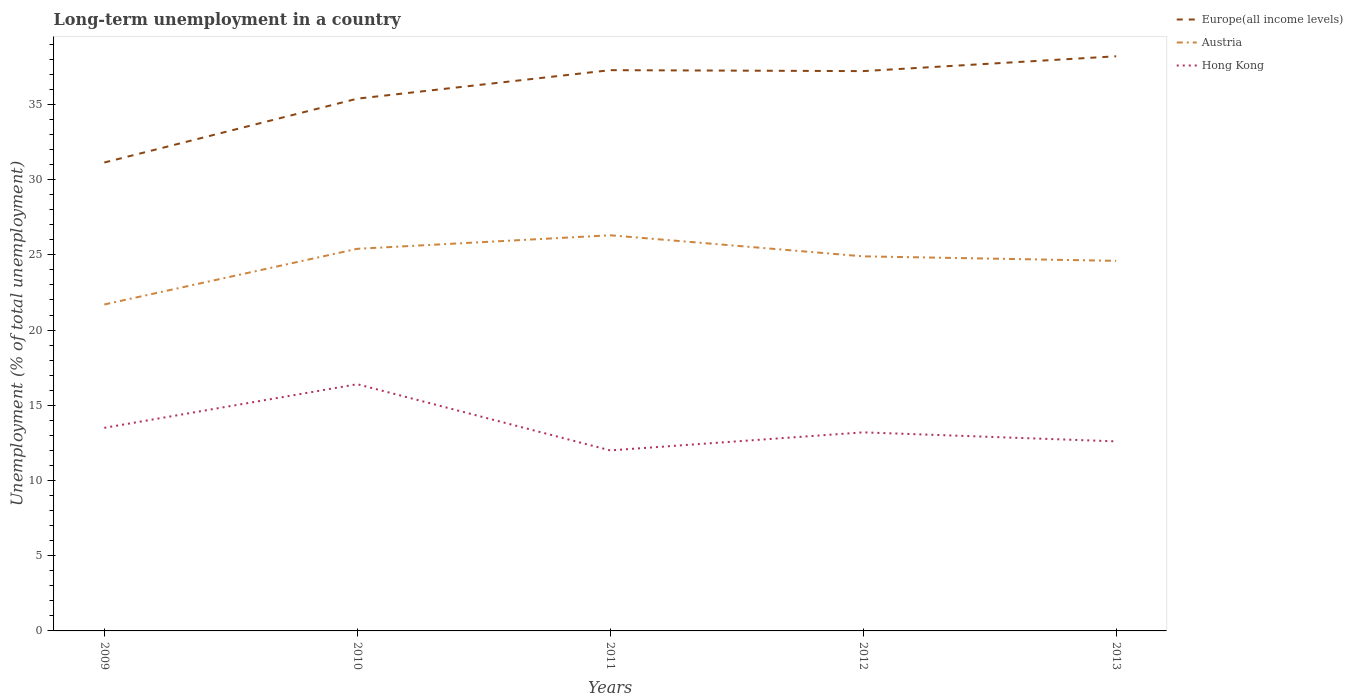How many different coloured lines are there?
Provide a succinct answer. 3. Does the line corresponding to Hong Kong intersect with the line corresponding to Austria?
Your answer should be very brief. No. Is the number of lines equal to the number of legend labels?
Provide a succinct answer. Yes. Across all years, what is the maximum percentage of long-term unemployed population in Austria?
Offer a terse response. 21.7. What is the total percentage of long-term unemployed population in Hong Kong in the graph?
Your response must be concise. 0.9. What is the difference between the highest and the second highest percentage of long-term unemployed population in Europe(all income levels)?
Offer a very short reply. 7.06. Is the percentage of long-term unemployed population in Austria strictly greater than the percentage of long-term unemployed population in Hong Kong over the years?
Keep it short and to the point. No. How many lines are there?
Your response must be concise. 3. How many years are there in the graph?
Provide a succinct answer. 5. What is the difference between two consecutive major ticks on the Y-axis?
Ensure brevity in your answer.  5. Where does the legend appear in the graph?
Your answer should be very brief. Top right. How are the legend labels stacked?
Provide a short and direct response. Vertical. What is the title of the graph?
Ensure brevity in your answer.  Long-term unemployment in a country. Does "Tunisia" appear as one of the legend labels in the graph?
Provide a short and direct response. No. What is the label or title of the Y-axis?
Make the answer very short. Unemployment (% of total unemployment). What is the Unemployment (% of total unemployment) in Europe(all income levels) in 2009?
Give a very brief answer. 31.14. What is the Unemployment (% of total unemployment) of Austria in 2009?
Offer a terse response. 21.7. What is the Unemployment (% of total unemployment) in Europe(all income levels) in 2010?
Give a very brief answer. 35.38. What is the Unemployment (% of total unemployment) of Austria in 2010?
Your response must be concise. 25.4. What is the Unemployment (% of total unemployment) of Hong Kong in 2010?
Ensure brevity in your answer.  16.4. What is the Unemployment (% of total unemployment) in Europe(all income levels) in 2011?
Provide a short and direct response. 37.28. What is the Unemployment (% of total unemployment) in Austria in 2011?
Provide a succinct answer. 26.3. What is the Unemployment (% of total unemployment) in Europe(all income levels) in 2012?
Ensure brevity in your answer.  37.21. What is the Unemployment (% of total unemployment) in Austria in 2012?
Keep it short and to the point. 24.9. What is the Unemployment (% of total unemployment) in Hong Kong in 2012?
Make the answer very short. 13.2. What is the Unemployment (% of total unemployment) of Europe(all income levels) in 2013?
Offer a terse response. 38.2. What is the Unemployment (% of total unemployment) of Austria in 2013?
Your answer should be compact. 24.6. What is the Unemployment (% of total unemployment) in Hong Kong in 2013?
Offer a very short reply. 12.6. Across all years, what is the maximum Unemployment (% of total unemployment) in Europe(all income levels)?
Ensure brevity in your answer.  38.2. Across all years, what is the maximum Unemployment (% of total unemployment) in Austria?
Give a very brief answer. 26.3. Across all years, what is the maximum Unemployment (% of total unemployment) of Hong Kong?
Keep it short and to the point. 16.4. Across all years, what is the minimum Unemployment (% of total unemployment) of Europe(all income levels)?
Give a very brief answer. 31.14. Across all years, what is the minimum Unemployment (% of total unemployment) of Austria?
Your response must be concise. 21.7. What is the total Unemployment (% of total unemployment) of Europe(all income levels) in the graph?
Offer a very short reply. 179.2. What is the total Unemployment (% of total unemployment) in Austria in the graph?
Your response must be concise. 122.9. What is the total Unemployment (% of total unemployment) of Hong Kong in the graph?
Your response must be concise. 67.7. What is the difference between the Unemployment (% of total unemployment) of Europe(all income levels) in 2009 and that in 2010?
Your answer should be very brief. -4.24. What is the difference between the Unemployment (% of total unemployment) in Austria in 2009 and that in 2010?
Give a very brief answer. -3.7. What is the difference between the Unemployment (% of total unemployment) of Hong Kong in 2009 and that in 2010?
Offer a very short reply. -2.9. What is the difference between the Unemployment (% of total unemployment) in Europe(all income levels) in 2009 and that in 2011?
Offer a terse response. -6.14. What is the difference between the Unemployment (% of total unemployment) in Hong Kong in 2009 and that in 2011?
Your response must be concise. 1.5. What is the difference between the Unemployment (% of total unemployment) of Europe(all income levels) in 2009 and that in 2012?
Provide a succinct answer. -6.08. What is the difference between the Unemployment (% of total unemployment) in Hong Kong in 2009 and that in 2012?
Offer a terse response. 0.3. What is the difference between the Unemployment (% of total unemployment) in Europe(all income levels) in 2009 and that in 2013?
Offer a terse response. -7.06. What is the difference between the Unemployment (% of total unemployment) in Austria in 2009 and that in 2013?
Offer a terse response. -2.9. What is the difference between the Unemployment (% of total unemployment) of Hong Kong in 2009 and that in 2013?
Your response must be concise. 0.9. What is the difference between the Unemployment (% of total unemployment) in Europe(all income levels) in 2010 and that in 2011?
Give a very brief answer. -1.89. What is the difference between the Unemployment (% of total unemployment) of Hong Kong in 2010 and that in 2011?
Give a very brief answer. 4.4. What is the difference between the Unemployment (% of total unemployment) of Europe(all income levels) in 2010 and that in 2012?
Provide a succinct answer. -1.83. What is the difference between the Unemployment (% of total unemployment) in Hong Kong in 2010 and that in 2012?
Your answer should be compact. 3.2. What is the difference between the Unemployment (% of total unemployment) of Europe(all income levels) in 2010 and that in 2013?
Your response must be concise. -2.82. What is the difference between the Unemployment (% of total unemployment) of Hong Kong in 2010 and that in 2013?
Make the answer very short. 3.8. What is the difference between the Unemployment (% of total unemployment) in Europe(all income levels) in 2011 and that in 2012?
Keep it short and to the point. 0.06. What is the difference between the Unemployment (% of total unemployment) of Europe(all income levels) in 2011 and that in 2013?
Offer a very short reply. -0.92. What is the difference between the Unemployment (% of total unemployment) in Hong Kong in 2011 and that in 2013?
Offer a terse response. -0.6. What is the difference between the Unemployment (% of total unemployment) of Europe(all income levels) in 2012 and that in 2013?
Offer a terse response. -0.99. What is the difference between the Unemployment (% of total unemployment) of Austria in 2012 and that in 2013?
Offer a very short reply. 0.3. What is the difference between the Unemployment (% of total unemployment) of Europe(all income levels) in 2009 and the Unemployment (% of total unemployment) of Austria in 2010?
Your response must be concise. 5.74. What is the difference between the Unemployment (% of total unemployment) of Europe(all income levels) in 2009 and the Unemployment (% of total unemployment) of Hong Kong in 2010?
Give a very brief answer. 14.74. What is the difference between the Unemployment (% of total unemployment) in Europe(all income levels) in 2009 and the Unemployment (% of total unemployment) in Austria in 2011?
Keep it short and to the point. 4.84. What is the difference between the Unemployment (% of total unemployment) in Europe(all income levels) in 2009 and the Unemployment (% of total unemployment) in Hong Kong in 2011?
Give a very brief answer. 19.14. What is the difference between the Unemployment (% of total unemployment) in Austria in 2009 and the Unemployment (% of total unemployment) in Hong Kong in 2011?
Keep it short and to the point. 9.7. What is the difference between the Unemployment (% of total unemployment) in Europe(all income levels) in 2009 and the Unemployment (% of total unemployment) in Austria in 2012?
Your answer should be compact. 6.24. What is the difference between the Unemployment (% of total unemployment) of Europe(all income levels) in 2009 and the Unemployment (% of total unemployment) of Hong Kong in 2012?
Keep it short and to the point. 17.94. What is the difference between the Unemployment (% of total unemployment) of Europe(all income levels) in 2009 and the Unemployment (% of total unemployment) of Austria in 2013?
Your response must be concise. 6.54. What is the difference between the Unemployment (% of total unemployment) of Europe(all income levels) in 2009 and the Unemployment (% of total unemployment) of Hong Kong in 2013?
Provide a short and direct response. 18.54. What is the difference between the Unemployment (% of total unemployment) of Austria in 2009 and the Unemployment (% of total unemployment) of Hong Kong in 2013?
Ensure brevity in your answer.  9.1. What is the difference between the Unemployment (% of total unemployment) of Europe(all income levels) in 2010 and the Unemployment (% of total unemployment) of Austria in 2011?
Keep it short and to the point. 9.08. What is the difference between the Unemployment (% of total unemployment) of Europe(all income levels) in 2010 and the Unemployment (% of total unemployment) of Hong Kong in 2011?
Provide a short and direct response. 23.38. What is the difference between the Unemployment (% of total unemployment) in Europe(all income levels) in 2010 and the Unemployment (% of total unemployment) in Austria in 2012?
Your response must be concise. 10.48. What is the difference between the Unemployment (% of total unemployment) in Europe(all income levels) in 2010 and the Unemployment (% of total unemployment) in Hong Kong in 2012?
Keep it short and to the point. 22.18. What is the difference between the Unemployment (% of total unemployment) of Austria in 2010 and the Unemployment (% of total unemployment) of Hong Kong in 2012?
Your response must be concise. 12.2. What is the difference between the Unemployment (% of total unemployment) of Europe(all income levels) in 2010 and the Unemployment (% of total unemployment) of Austria in 2013?
Give a very brief answer. 10.78. What is the difference between the Unemployment (% of total unemployment) of Europe(all income levels) in 2010 and the Unemployment (% of total unemployment) of Hong Kong in 2013?
Provide a short and direct response. 22.78. What is the difference between the Unemployment (% of total unemployment) of Austria in 2010 and the Unemployment (% of total unemployment) of Hong Kong in 2013?
Keep it short and to the point. 12.8. What is the difference between the Unemployment (% of total unemployment) in Europe(all income levels) in 2011 and the Unemployment (% of total unemployment) in Austria in 2012?
Make the answer very short. 12.38. What is the difference between the Unemployment (% of total unemployment) in Europe(all income levels) in 2011 and the Unemployment (% of total unemployment) in Hong Kong in 2012?
Your response must be concise. 24.08. What is the difference between the Unemployment (% of total unemployment) of Austria in 2011 and the Unemployment (% of total unemployment) of Hong Kong in 2012?
Your answer should be compact. 13.1. What is the difference between the Unemployment (% of total unemployment) in Europe(all income levels) in 2011 and the Unemployment (% of total unemployment) in Austria in 2013?
Provide a succinct answer. 12.68. What is the difference between the Unemployment (% of total unemployment) in Europe(all income levels) in 2011 and the Unemployment (% of total unemployment) in Hong Kong in 2013?
Offer a very short reply. 24.68. What is the difference between the Unemployment (% of total unemployment) of Europe(all income levels) in 2012 and the Unemployment (% of total unemployment) of Austria in 2013?
Offer a very short reply. 12.61. What is the difference between the Unemployment (% of total unemployment) in Europe(all income levels) in 2012 and the Unemployment (% of total unemployment) in Hong Kong in 2013?
Your response must be concise. 24.61. What is the difference between the Unemployment (% of total unemployment) in Austria in 2012 and the Unemployment (% of total unemployment) in Hong Kong in 2013?
Provide a succinct answer. 12.3. What is the average Unemployment (% of total unemployment) in Europe(all income levels) per year?
Your answer should be compact. 35.84. What is the average Unemployment (% of total unemployment) of Austria per year?
Offer a terse response. 24.58. What is the average Unemployment (% of total unemployment) in Hong Kong per year?
Offer a very short reply. 13.54. In the year 2009, what is the difference between the Unemployment (% of total unemployment) of Europe(all income levels) and Unemployment (% of total unemployment) of Austria?
Offer a very short reply. 9.44. In the year 2009, what is the difference between the Unemployment (% of total unemployment) in Europe(all income levels) and Unemployment (% of total unemployment) in Hong Kong?
Your answer should be very brief. 17.64. In the year 2009, what is the difference between the Unemployment (% of total unemployment) of Austria and Unemployment (% of total unemployment) of Hong Kong?
Provide a succinct answer. 8.2. In the year 2010, what is the difference between the Unemployment (% of total unemployment) of Europe(all income levels) and Unemployment (% of total unemployment) of Austria?
Give a very brief answer. 9.98. In the year 2010, what is the difference between the Unemployment (% of total unemployment) in Europe(all income levels) and Unemployment (% of total unemployment) in Hong Kong?
Your answer should be compact. 18.98. In the year 2011, what is the difference between the Unemployment (% of total unemployment) of Europe(all income levels) and Unemployment (% of total unemployment) of Austria?
Give a very brief answer. 10.98. In the year 2011, what is the difference between the Unemployment (% of total unemployment) of Europe(all income levels) and Unemployment (% of total unemployment) of Hong Kong?
Your response must be concise. 25.28. In the year 2012, what is the difference between the Unemployment (% of total unemployment) in Europe(all income levels) and Unemployment (% of total unemployment) in Austria?
Make the answer very short. 12.31. In the year 2012, what is the difference between the Unemployment (% of total unemployment) of Europe(all income levels) and Unemployment (% of total unemployment) of Hong Kong?
Offer a very short reply. 24.01. In the year 2012, what is the difference between the Unemployment (% of total unemployment) of Austria and Unemployment (% of total unemployment) of Hong Kong?
Your answer should be compact. 11.7. In the year 2013, what is the difference between the Unemployment (% of total unemployment) in Europe(all income levels) and Unemployment (% of total unemployment) in Austria?
Give a very brief answer. 13.6. In the year 2013, what is the difference between the Unemployment (% of total unemployment) of Europe(all income levels) and Unemployment (% of total unemployment) of Hong Kong?
Make the answer very short. 25.6. In the year 2013, what is the difference between the Unemployment (% of total unemployment) of Austria and Unemployment (% of total unemployment) of Hong Kong?
Offer a very short reply. 12. What is the ratio of the Unemployment (% of total unemployment) of Europe(all income levels) in 2009 to that in 2010?
Provide a succinct answer. 0.88. What is the ratio of the Unemployment (% of total unemployment) in Austria in 2009 to that in 2010?
Provide a succinct answer. 0.85. What is the ratio of the Unemployment (% of total unemployment) in Hong Kong in 2009 to that in 2010?
Make the answer very short. 0.82. What is the ratio of the Unemployment (% of total unemployment) in Europe(all income levels) in 2009 to that in 2011?
Keep it short and to the point. 0.84. What is the ratio of the Unemployment (% of total unemployment) of Austria in 2009 to that in 2011?
Offer a very short reply. 0.83. What is the ratio of the Unemployment (% of total unemployment) in Hong Kong in 2009 to that in 2011?
Ensure brevity in your answer.  1.12. What is the ratio of the Unemployment (% of total unemployment) in Europe(all income levels) in 2009 to that in 2012?
Your response must be concise. 0.84. What is the ratio of the Unemployment (% of total unemployment) in Austria in 2009 to that in 2012?
Provide a succinct answer. 0.87. What is the ratio of the Unemployment (% of total unemployment) in Hong Kong in 2009 to that in 2012?
Keep it short and to the point. 1.02. What is the ratio of the Unemployment (% of total unemployment) in Europe(all income levels) in 2009 to that in 2013?
Give a very brief answer. 0.82. What is the ratio of the Unemployment (% of total unemployment) of Austria in 2009 to that in 2013?
Ensure brevity in your answer.  0.88. What is the ratio of the Unemployment (% of total unemployment) of Hong Kong in 2009 to that in 2013?
Provide a succinct answer. 1.07. What is the ratio of the Unemployment (% of total unemployment) of Europe(all income levels) in 2010 to that in 2011?
Your answer should be very brief. 0.95. What is the ratio of the Unemployment (% of total unemployment) in Austria in 2010 to that in 2011?
Your answer should be very brief. 0.97. What is the ratio of the Unemployment (% of total unemployment) in Hong Kong in 2010 to that in 2011?
Make the answer very short. 1.37. What is the ratio of the Unemployment (% of total unemployment) in Europe(all income levels) in 2010 to that in 2012?
Give a very brief answer. 0.95. What is the ratio of the Unemployment (% of total unemployment) in Austria in 2010 to that in 2012?
Offer a terse response. 1.02. What is the ratio of the Unemployment (% of total unemployment) in Hong Kong in 2010 to that in 2012?
Keep it short and to the point. 1.24. What is the ratio of the Unemployment (% of total unemployment) in Europe(all income levels) in 2010 to that in 2013?
Offer a terse response. 0.93. What is the ratio of the Unemployment (% of total unemployment) in Austria in 2010 to that in 2013?
Your answer should be compact. 1.03. What is the ratio of the Unemployment (% of total unemployment) of Hong Kong in 2010 to that in 2013?
Your answer should be compact. 1.3. What is the ratio of the Unemployment (% of total unemployment) in Austria in 2011 to that in 2012?
Provide a succinct answer. 1.06. What is the ratio of the Unemployment (% of total unemployment) of Europe(all income levels) in 2011 to that in 2013?
Your response must be concise. 0.98. What is the ratio of the Unemployment (% of total unemployment) in Austria in 2011 to that in 2013?
Provide a short and direct response. 1.07. What is the ratio of the Unemployment (% of total unemployment) in Hong Kong in 2011 to that in 2013?
Ensure brevity in your answer.  0.95. What is the ratio of the Unemployment (% of total unemployment) of Europe(all income levels) in 2012 to that in 2013?
Your response must be concise. 0.97. What is the ratio of the Unemployment (% of total unemployment) of Austria in 2012 to that in 2013?
Make the answer very short. 1.01. What is the ratio of the Unemployment (% of total unemployment) of Hong Kong in 2012 to that in 2013?
Your answer should be compact. 1.05. What is the difference between the highest and the second highest Unemployment (% of total unemployment) of Europe(all income levels)?
Offer a terse response. 0.92. What is the difference between the highest and the second highest Unemployment (% of total unemployment) in Hong Kong?
Ensure brevity in your answer.  2.9. What is the difference between the highest and the lowest Unemployment (% of total unemployment) of Europe(all income levels)?
Ensure brevity in your answer.  7.06. What is the difference between the highest and the lowest Unemployment (% of total unemployment) of Hong Kong?
Make the answer very short. 4.4. 